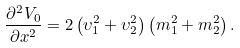Convert formula to latex. <formula><loc_0><loc_0><loc_500><loc_500>\frac { \partial ^ { 2 } V _ { 0 } } { \partial x ^ { 2 } } = 2 \left ( \upsilon _ { 1 } ^ { 2 } + \upsilon _ { 2 } ^ { 2 } \right ) \left ( m _ { 1 } ^ { 2 } + m _ { 2 } ^ { 2 } \right ) .</formula> 